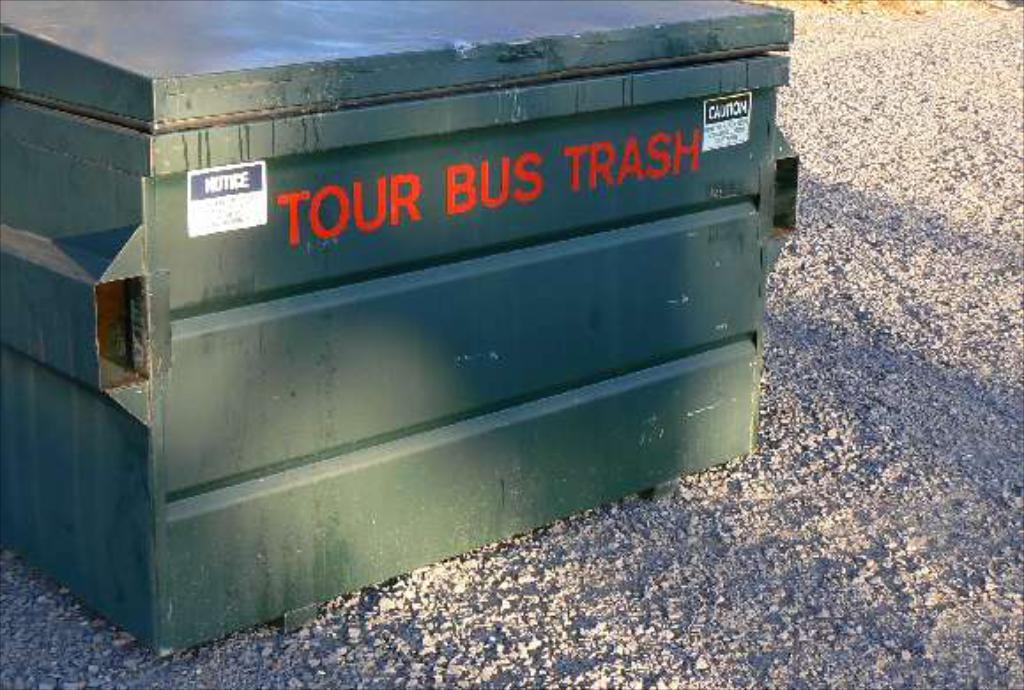<image>
Write a terse but informative summary of the picture. Tour Bus Trash is painted onto the side of this dumpster. 